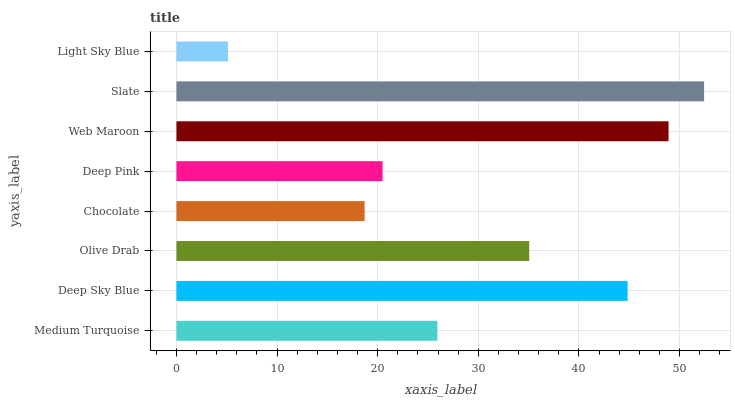Is Light Sky Blue the minimum?
Answer yes or no. Yes. Is Slate the maximum?
Answer yes or no. Yes. Is Deep Sky Blue the minimum?
Answer yes or no. No. Is Deep Sky Blue the maximum?
Answer yes or no. No. Is Deep Sky Blue greater than Medium Turquoise?
Answer yes or no. Yes. Is Medium Turquoise less than Deep Sky Blue?
Answer yes or no. Yes. Is Medium Turquoise greater than Deep Sky Blue?
Answer yes or no. No. Is Deep Sky Blue less than Medium Turquoise?
Answer yes or no. No. Is Olive Drab the high median?
Answer yes or no. Yes. Is Medium Turquoise the low median?
Answer yes or no. Yes. Is Deep Sky Blue the high median?
Answer yes or no. No. Is Web Maroon the low median?
Answer yes or no. No. 